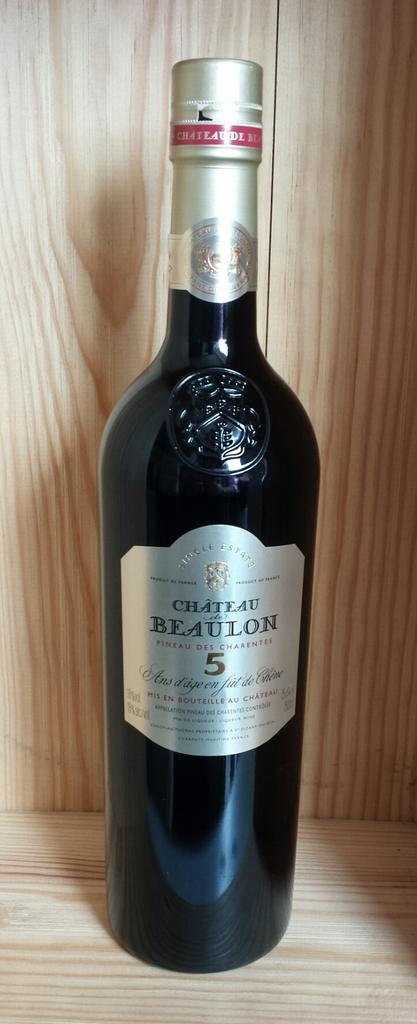What number is shown on the label?
Provide a succinct answer. 5. Who made this bottle of wine?
Make the answer very short. Chateau beaulon. 